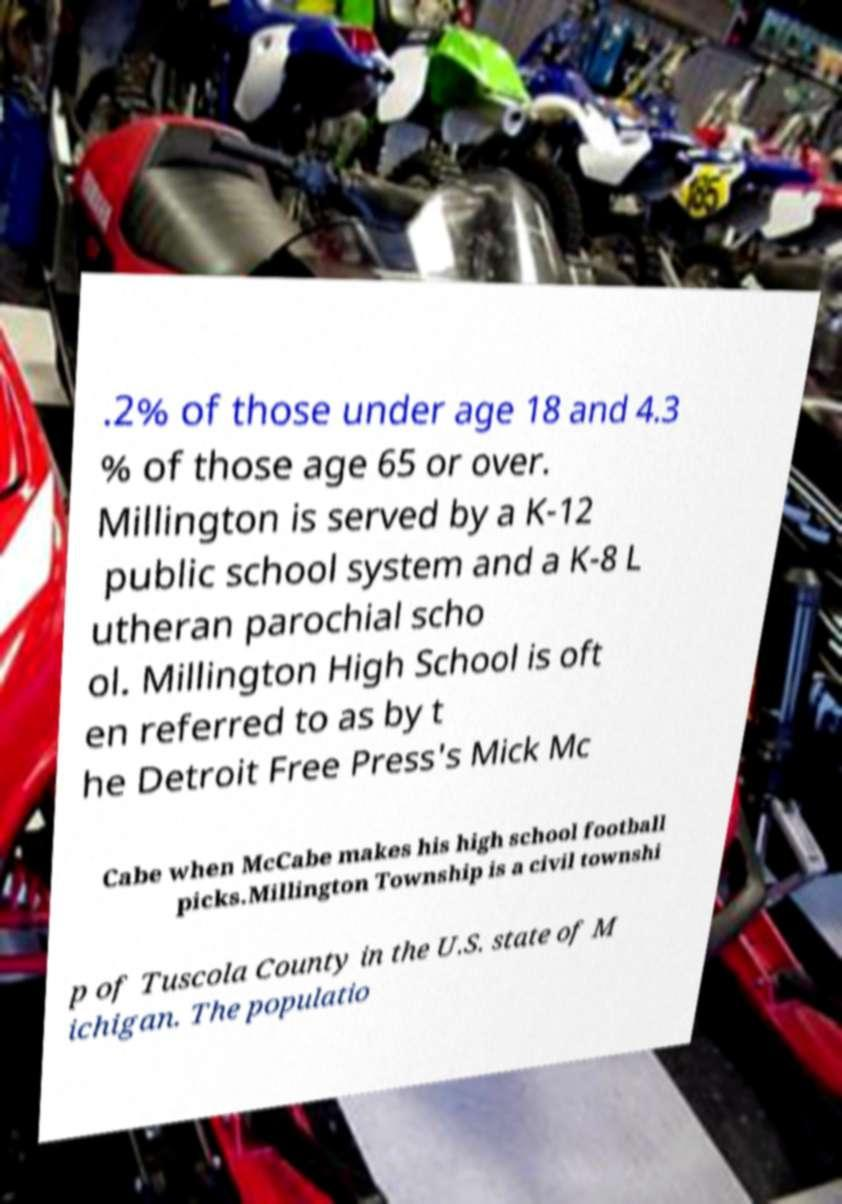Please identify and transcribe the text found in this image. .2% of those under age 18 and 4.3 % of those age 65 or over. Millington is served by a K-12 public school system and a K-8 L utheran parochial scho ol. Millington High School is oft en referred to as by t he Detroit Free Press's Mick Mc Cabe when McCabe makes his high school football picks.Millington Township is a civil townshi p of Tuscola County in the U.S. state of M ichigan. The populatio 